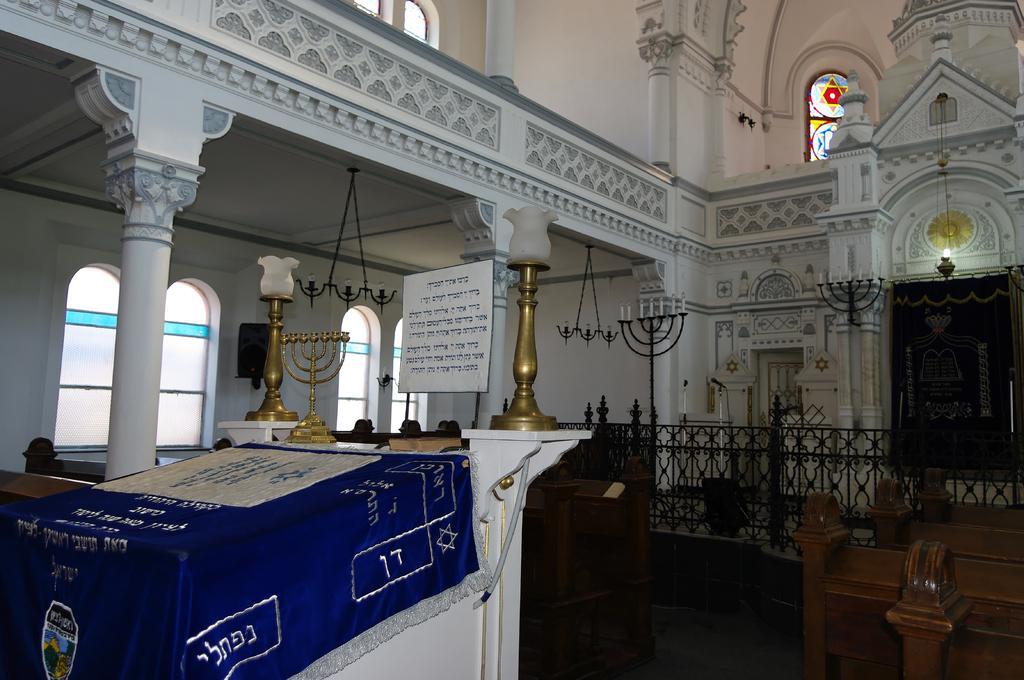Could you give a brief overview of what you see in this image? In this picture we can see lights. On the right there is a door. Here we can see candle stand. On the top we can see windows. 